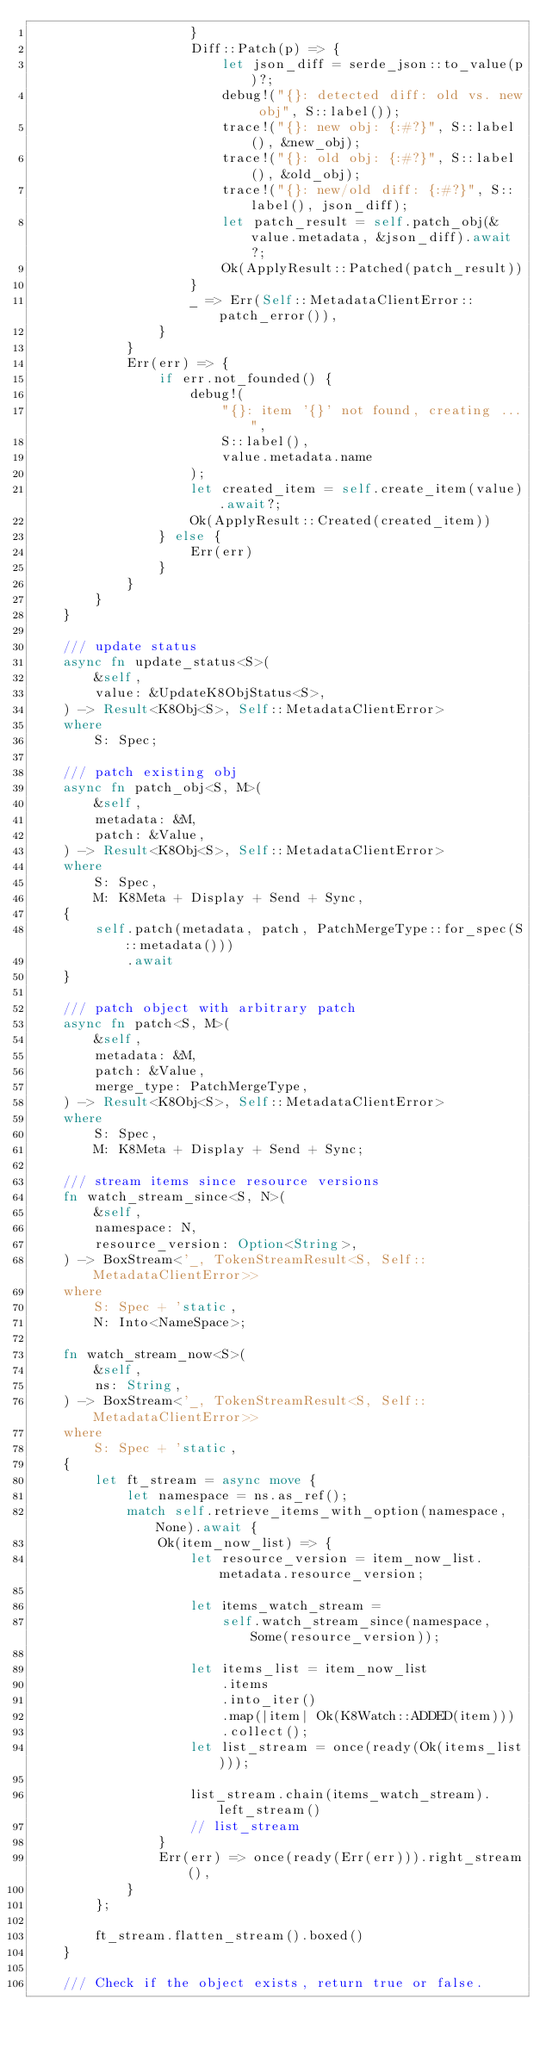Convert code to text. <code><loc_0><loc_0><loc_500><loc_500><_Rust_>                    }
                    Diff::Patch(p) => {
                        let json_diff = serde_json::to_value(p)?;
                        debug!("{}: detected diff: old vs. new obj", S::label());
                        trace!("{}: new obj: {:#?}", S::label(), &new_obj);
                        trace!("{}: old obj: {:#?}", S::label(), &old_obj);
                        trace!("{}: new/old diff: {:#?}", S::label(), json_diff);
                        let patch_result = self.patch_obj(&value.metadata, &json_diff).await?;
                        Ok(ApplyResult::Patched(patch_result))
                    }
                    _ => Err(Self::MetadataClientError::patch_error()),
                }
            }
            Err(err) => {
                if err.not_founded() {
                    debug!(
                        "{}: item '{}' not found, creating ...",
                        S::label(),
                        value.metadata.name
                    );
                    let created_item = self.create_item(value).await?;
                    Ok(ApplyResult::Created(created_item))
                } else {
                    Err(err)
                }
            }
        }
    }

    /// update status
    async fn update_status<S>(
        &self,
        value: &UpdateK8ObjStatus<S>,
    ) -> Result<K8Obj<S>, Self::MetadataClientError>
    where
        S: Spec;

    /// patch existing obj
    async fn patch_obj<S, M>(
        &self,
        metadata: &M,
        patch: &Value,
    ) -> Result<K8Obj<S>, Self::MetadataClientError>
    where
        S: Spec,
        M: K8Meta + Display + Send + Sync,
    {
        self.patch(metadata, patch, PatchMergeType::for_spec(S::metadata()))
            .await
    }

    /// patch object with arbitrary patch
    async fn patch<S, M>(
        &self,
        metadata: &M,
        patch: &Value,
        merge_type: PatchMergeType,
    ) -> Result<K8Obj<S>, Self::MetadataClientError>
    where
        S: Spec,
        M: K8Meta + Display + Send + Sync;

    /// stream items since resource versions
    fn watch_stream_since<S, N>(
        &self,
        namespace: N,
        resource_version: Option<String>,
    ) -> BoxStream<'_, TokenStreamResult<S, Self::MetadataClientError>>
    where
        S: Spec + 'static,
        N: Into<NameSpace>;

    fn watch_stream_now<S>(
        &self,
        ns: String,
    ) -> BoxStream<'_, TokenStreamResult<S, Self::MetadataClientError>>
    where
        S: Spec + 'static,
    {
        let ft_stream = async move {
            let namespace = ns.as_ref();
            match self.retrieve_items_with_option(namespace, None).await {
                Ok(item_now_list) => {
                    let resource_version = item_now_list.metadata.resource_version;

                    let items_watch_stream =
                        self.watch_stream_since(namespace, Some(resource_version));

                    let items_list = item_now_list
                        .items
                        .into_iter()
                        .map(|item| Ok(K8Watch::ADDED(item)))
                        .collect();
                    let list_stream = once(ready(Ok(items_list)));

                    list_stream.chain(items_watch_stream).left_stream()
                    // list_stream
                }
                Err(err) => once(ready(Err(err))).right_stream(),
            }
        };

        ft_stream.flatten_stream().boxed()
    }

    /// Check if the object exists, return true or false.</code> 